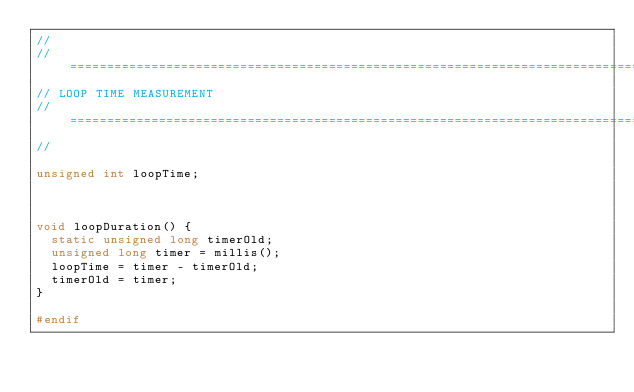<code> <loc_0><loc_0><loc_500><loc_500><_C_>//
// =======================================================================================================
// LOOP TIME MEASUREMENT
// =======================================================================================================
//

unsigned int loopTime;



void loopDuration() {
  static unsigned long timerOld;
  unsigned long timer = millis();
  loopTime = timer - timerOld;
  timerOld = timer;
}

#endif
</code> 